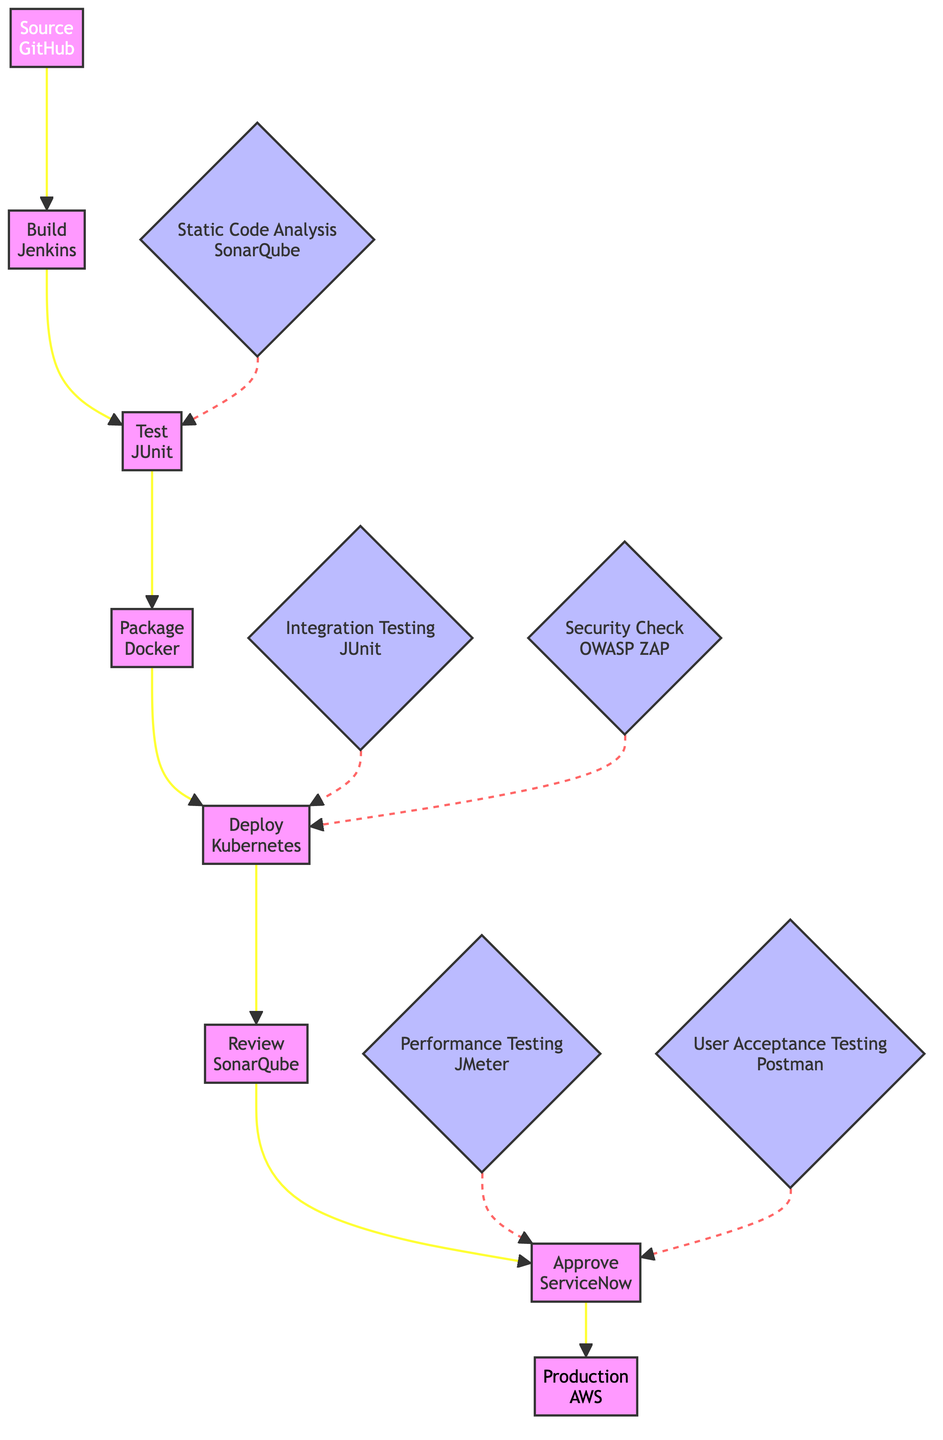What is the first stage in the code deployment pipeline? The first stage is identified as "Source", where the source code is retrieved from the repository using GitHub. This can be confirmed by looking at the arrow leading from "Source" to the next stage.
Answer: Source How many stages are there in the code deployment pipeline? The diagram shows a total of eight stages from "Source" to "Production". This can be counted directly by identifying each labeled node listed in the stages.
Answer: Eight What tool is used in the "Test" stage? The tool associated with the "Test" stage is specified as "JUnit". This can be seen from the label on the "Test" node in the flowchart.
Answer: JUnit Which quality gate is checked before the "Deploy" stage? The quality gates checked before the "Deploy" stage are "Integration Testing" and "Security Check", both indicated by dashed arrows pointing to the "Deploy" node from their respective quality gate nodes.
Answer: Integration Testing, Security Check In what environment is the code deployed in the final stage? The final stage, labeled "Production", indicates that the code is deployed in the production environment, and it is associated with the tool "AWS". This information is visible in the label of the "Production" node.
Answer: Production environment What is the purpose of the "Review" stage? The "Review" stage is defined for code peer-review and verifying quality gates. This function can be deduced from the description in the "Review" node, linking it to quality assurance efforts.
Answer: Peer review and quality gates verification How is the "Approve" stage connected to the quality gates? The "Approve" stage is preceded by "Performance Testing" and "User Acceptance Testing", as indicated by the arrows connecting these quality gates to the "Approve" stage. This demonstrates that approval comes after these validations are completed.
Answer: After Performance Testing and User Acceptance Testing Name two tools used in the packaging and deployment stages. The tools used in the "Package" stage is "Docker" and in the "Deploy" stage is "Kubernetes". Each tool is explicitly mentioned in the respective stage nodes, forming a direct association.
Answer: Docker, Kubernetes 